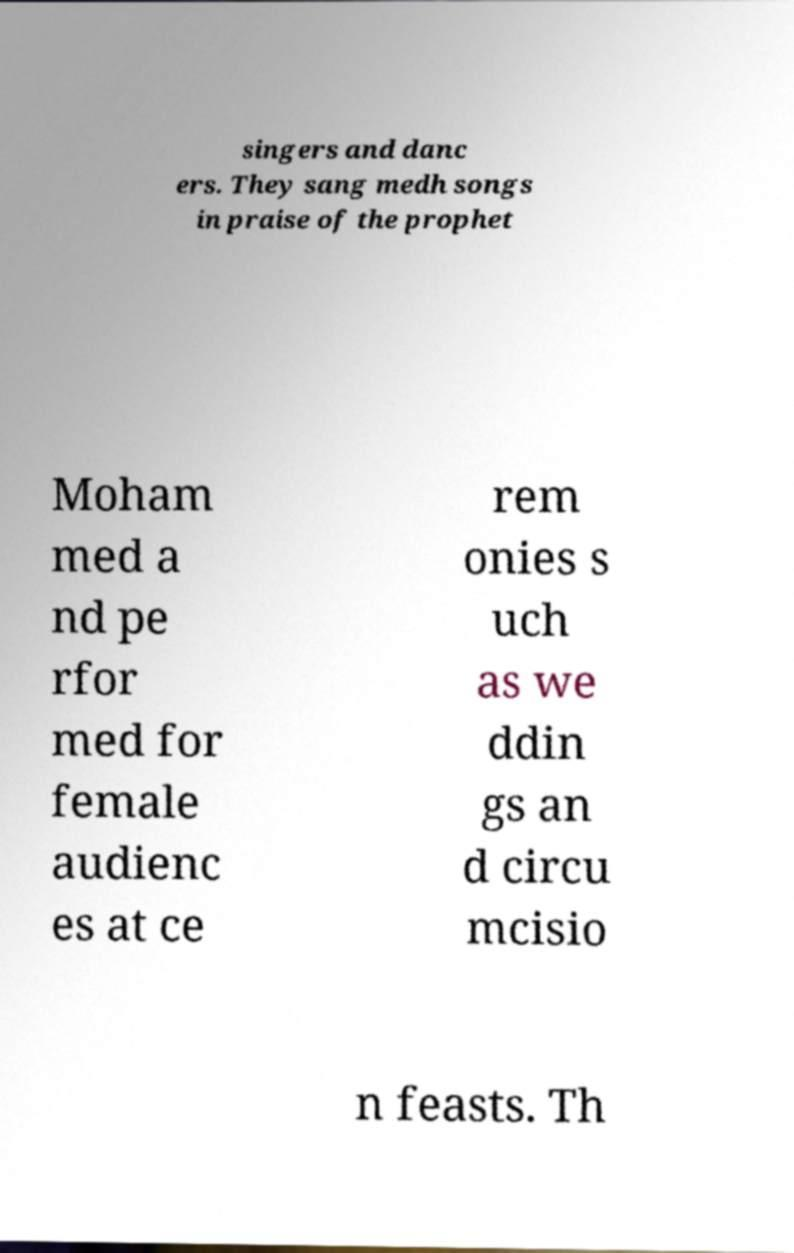Could you assist in decoding the text presented in this image and type it out clearly? singers and danc ers. They sang medh songs in praise of the prophet Moham med a nd pe rfor med for female audienc es at ce rem onies s uch as we ddin gs an d circu mcisio n feasts. Th 